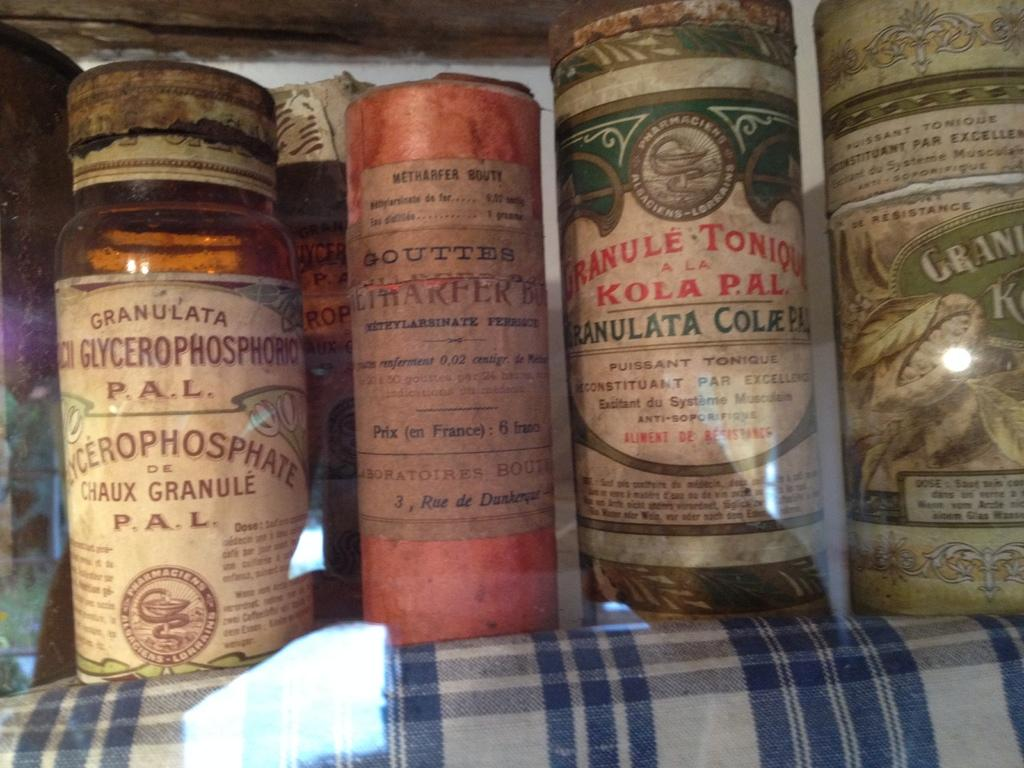<image>
Write a terse but informative summary of the picture. candles next to one another that say 'glycerophosphoric' 